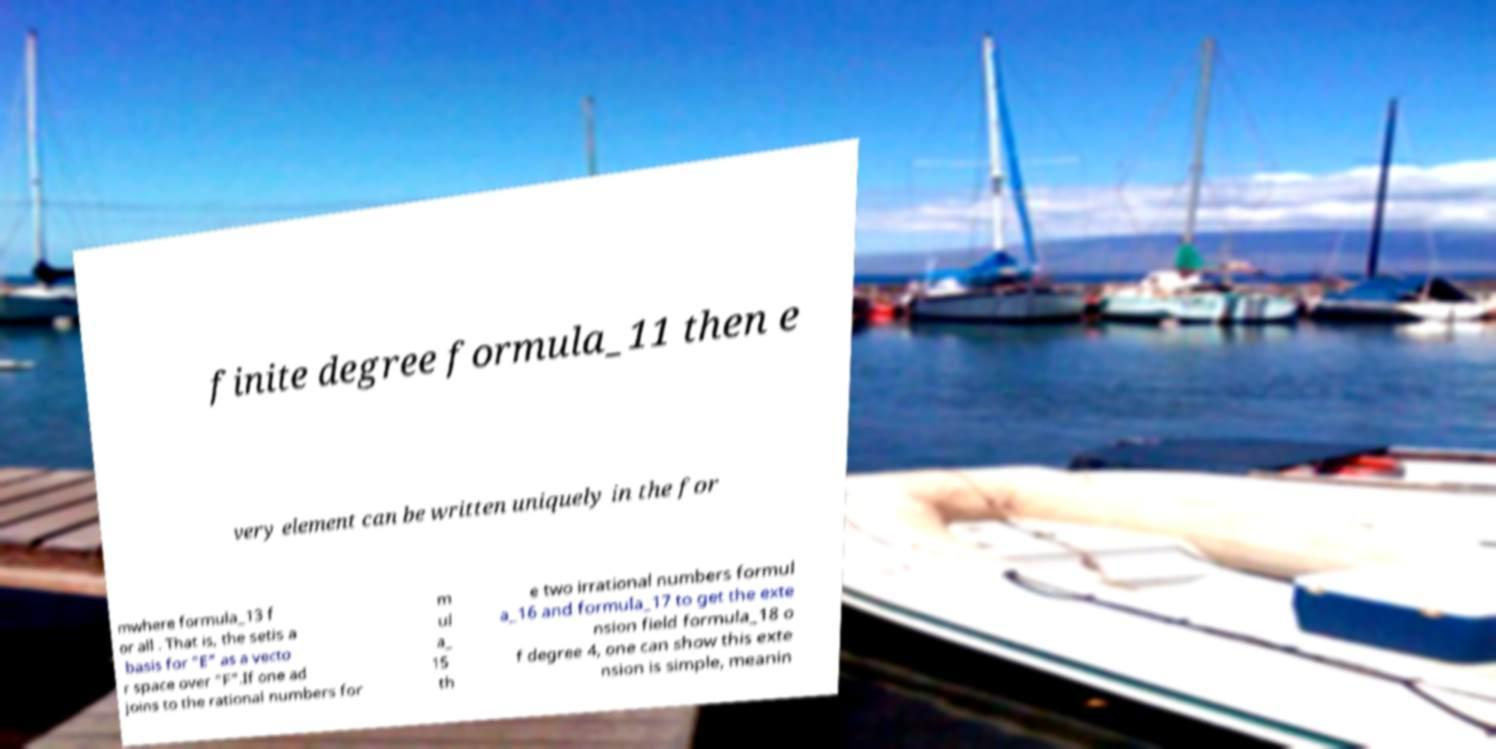Could you extract and type out the text from this image? finite degree formula_11 then e very element can be written uniquely in the for mwhere formula_13 f or all . That is, the setis a basis for "E" as a vecto r space over "F".If one ad joins to the rational numbers for m ul a_ 15 th e two irrational numbers formul a_16 and formula_17 to get the exte nsion field formula_18 o f degree 4, one can show this exte nsion is simple, meanin 